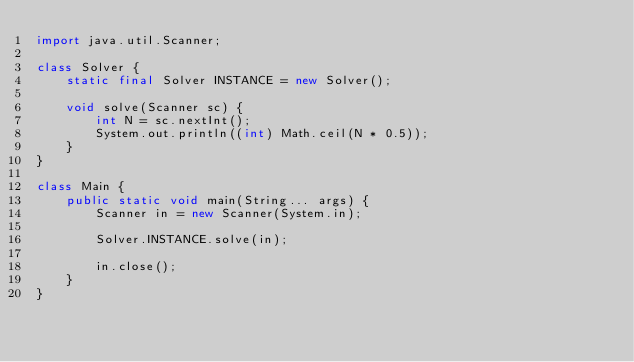Convert code to text. <code><loc_0><loc_0><loc_500><loc_500><_Java_>import java.util.Scanner;

class Solver {
	static final Solver INSTANCE = new Solver();

	void solve(Scanner sc) {
		int N = sc.nextInt();
		System.out.println((int) Math.ceil(N * 0.5));
	}
}

class Main {
	public static void main(String... args) {
		Scanner in = new Scanner(System.in);

		Solver.INSTANCE.solve(in);

		in.close();
	}
}</code> 